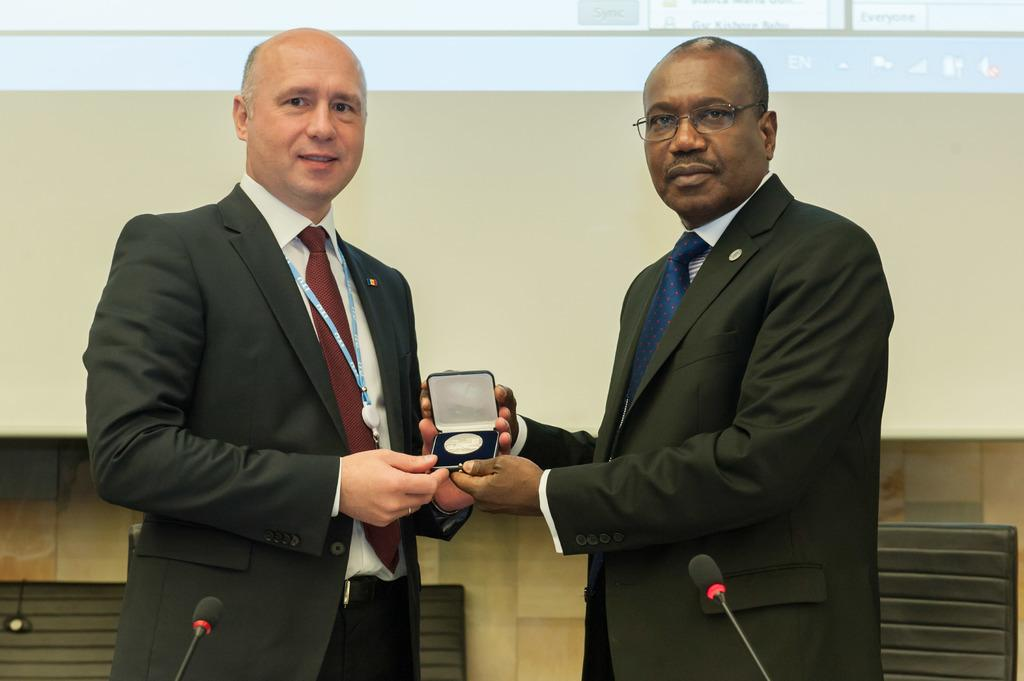How many people are in the image? There are two persons in the image. What are the persons holding in their hands? The persons are holding an object in their hands. What is in front of the persons? There are mice in front of the persons. What can be seen behind the persons? There are chairs behind the persons. What is hanging on the wall in the image? There is a screen hanging on the wall. What type of vein is visible on the jeans worn by the persons in the image? There is no mention of jeans or veins in the image; the persons are not wearing jeans, and there is no visible vein. 